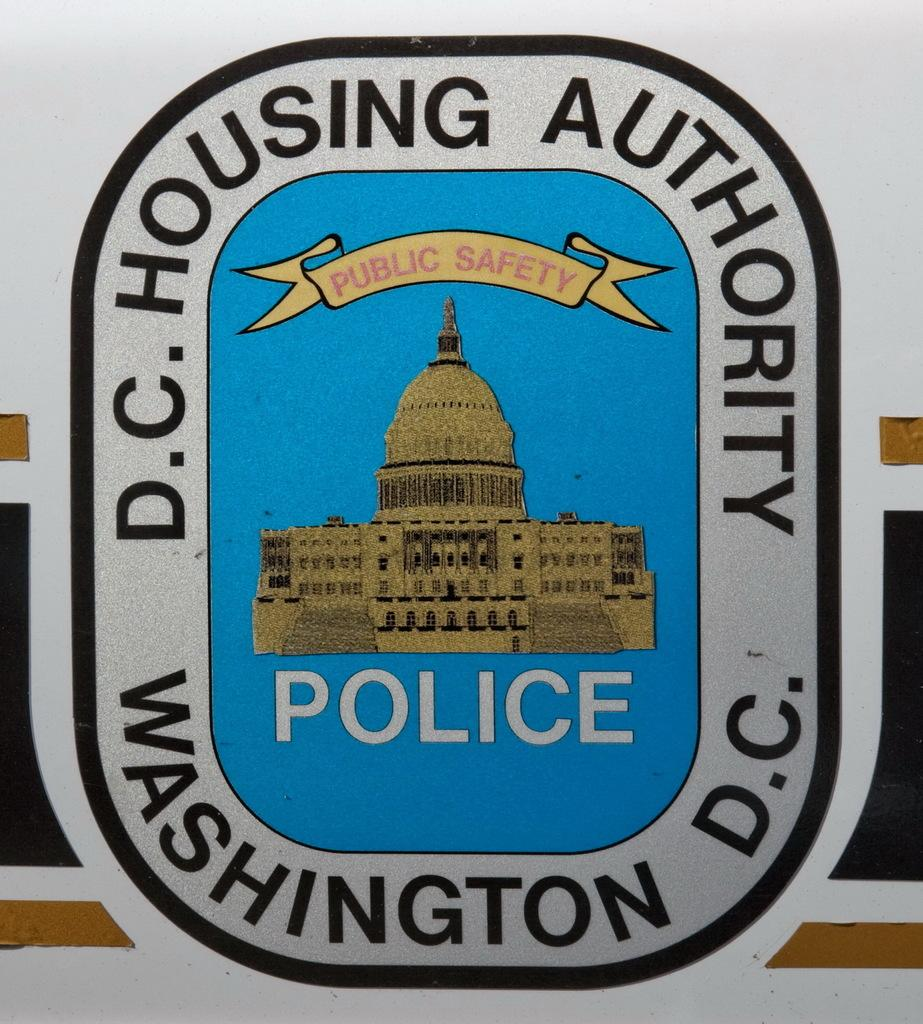<image>
Offer a succinct explanation of the picture presented. A sign for the police and the Washington D.C. Housing Authority. 